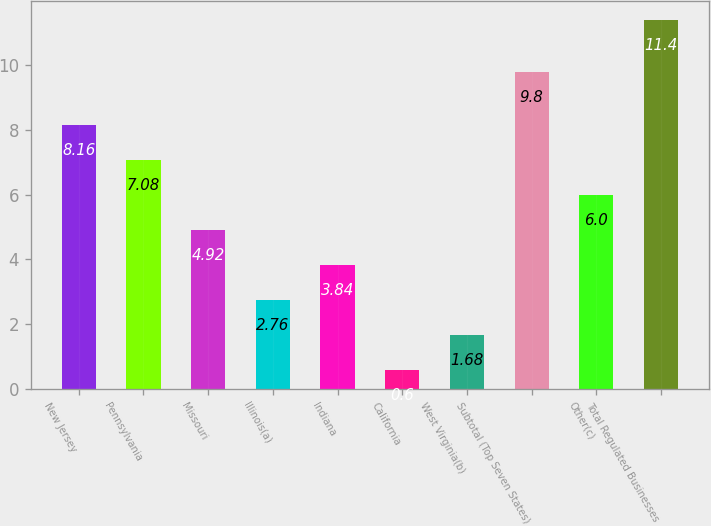Convert chart. <chart><loc_0><loc_0><loc_500><loc_500><bar_chart><fcel>New Jersey<fcel>Pennsylvania<fcel>Missouri<fcel>Illinois(a)<fcel>Indiana<fcel>California<fcel>West Virginia(b)<fcel>Subtotal (Top Seven States)<fcel>Other(c)<fcel>Total Regulated Businesses<nl><fcel>8.16<fcel>7.08<fcel>4.92<fcel>2.76<fcel>3.84<fcel>0.6<fcel>1.68<fcel>9.8<fcel>6<fcel>11.4<nl></chart> 